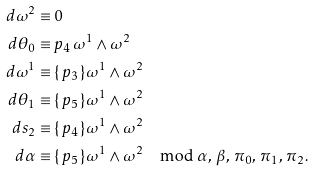<formula> <loc_0><loc_0><loc_500><loc_500>d \omega ^ { 2 } & \equiv 0 \\ d \theta _ { 0 } & \equiv p _ { 4 } \, \omega ^ { 1 } \wedge \omega ^ { 2 } \\ d \omega ^ { 1 } & \equiv \{ \, p _ { 3 } \, \} \omega ^ { 1 } \wedge \omega ^ { 2 } \\ d \theta _ { 1 } & \equiv \{ \, p _ { 5 } \, \} \omega ^ { 1 } \wedge \omega ^ { 2 } \\ d s _ { 2 } & \equiv \{ \, p _ { 4 } \, \} \omega ^ { 1 } \wedge \omega ^ { 2 } \\ d \alpha & \equiv \{ \, p _ { 5 } \, \} \omega ^ { 1 } \wedge \omega ^ { 2 } \mod \alpha , \, \beta , \, \pi _ { 0 } , \, \pi _ { 1 } , \, \pi _ { 2 } .</formula> 